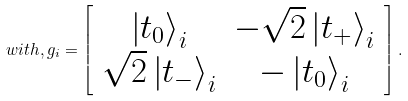Convert formula to latex. <formula><loc_0><loc_0><loc_500><loc_500>w i t h , g _ { i } = \left [ \begin{array} { c c } \left | t _ { 0 } \right \rangle _ { i } & - \sqrt { 2 } \left | t _ { + } \right \rangle _ { i } \\ \sqrt { 2 } \left | t _ { - } \right \rangle _ { i } & - \left | t _ { 0 } \right \rangle _ { i } \end{array} \right ] .</formula> 